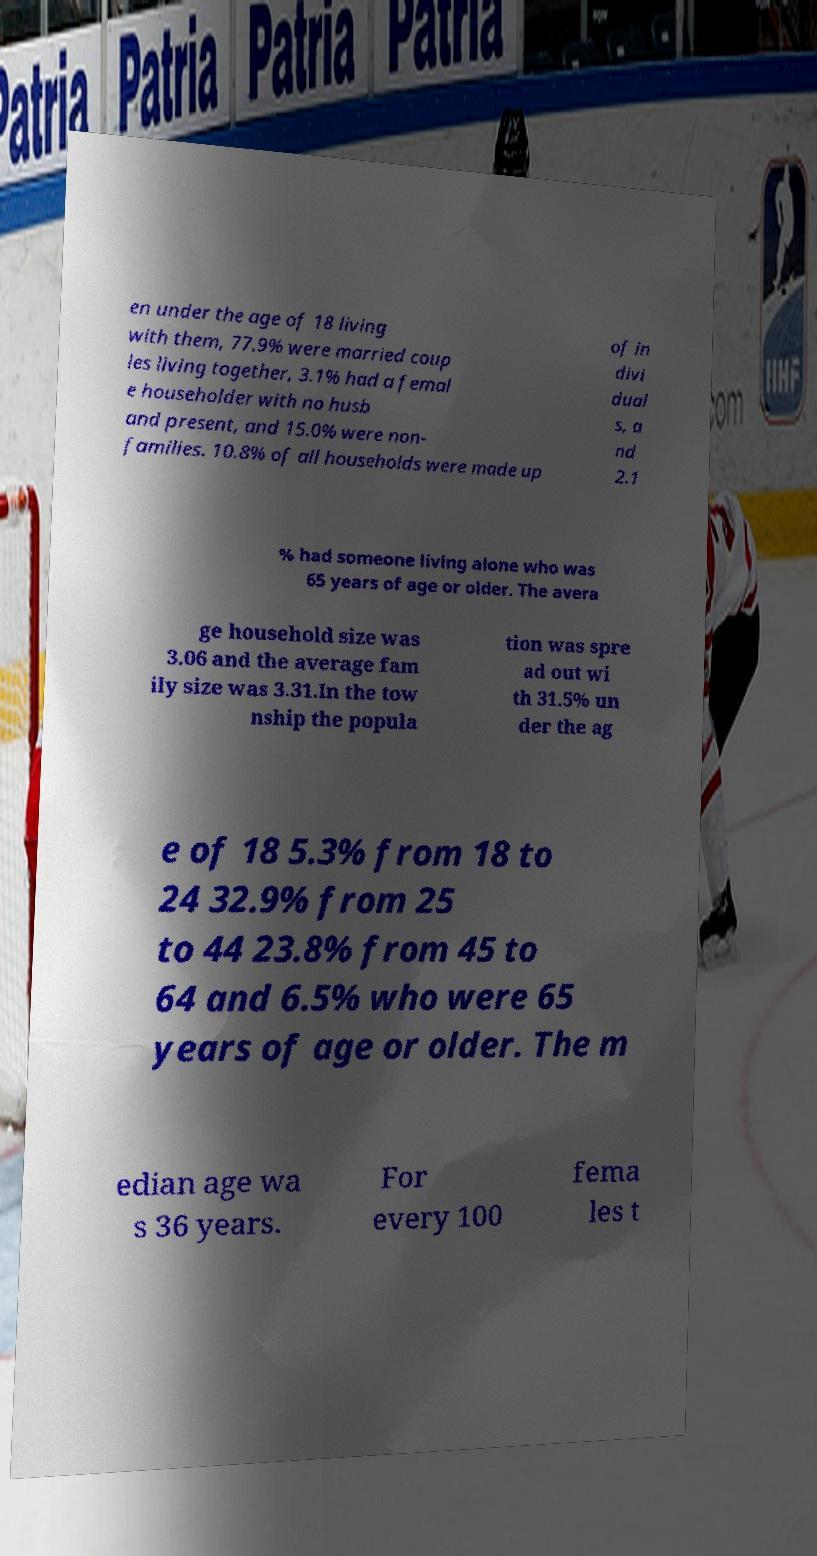I need the written content from this picture converted into text. Can you do that? en under the age of 18 living with them, 77.9% were married coup les living together, 3.1% had a femal e householder with no husb and present, and 15.0% were non- families. 10.8% of all households were made up of in divi dual s, a nd 2.1 % had someone living alone who was 65 years of age or older. The avera ge household size was 3.06 and the average fam ily size was 3.31.In the tow nship the popula tion was spre ad out wi th 31.5% un der the ag e of 18 5.3% from 18 to 24 32.9% from 25 to 44 23.8% from 45 to 64 and 6.5% who were 65 years of age or older. The m edian age wa s 36 years. For every 100 fema les t 